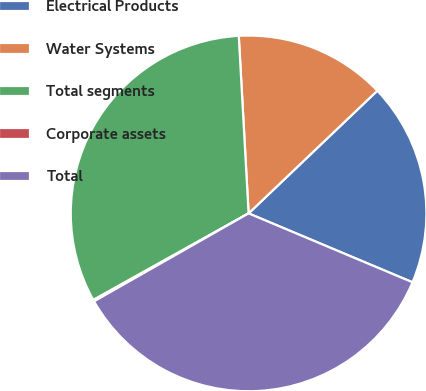Convert chart to OTSL. <chart><loc_0><loc_0><loc_500><loc_500><pie_chart><fcel>Electrical Products<fcel>Water Systems<fcel>Total segments<fcel>Corporate assets<fcel>Total<nl><fcel>18.45%<fcel>13.76%<fcel>32.21%<fcel>0.14%<fcel>35.43%<nl></chart> 